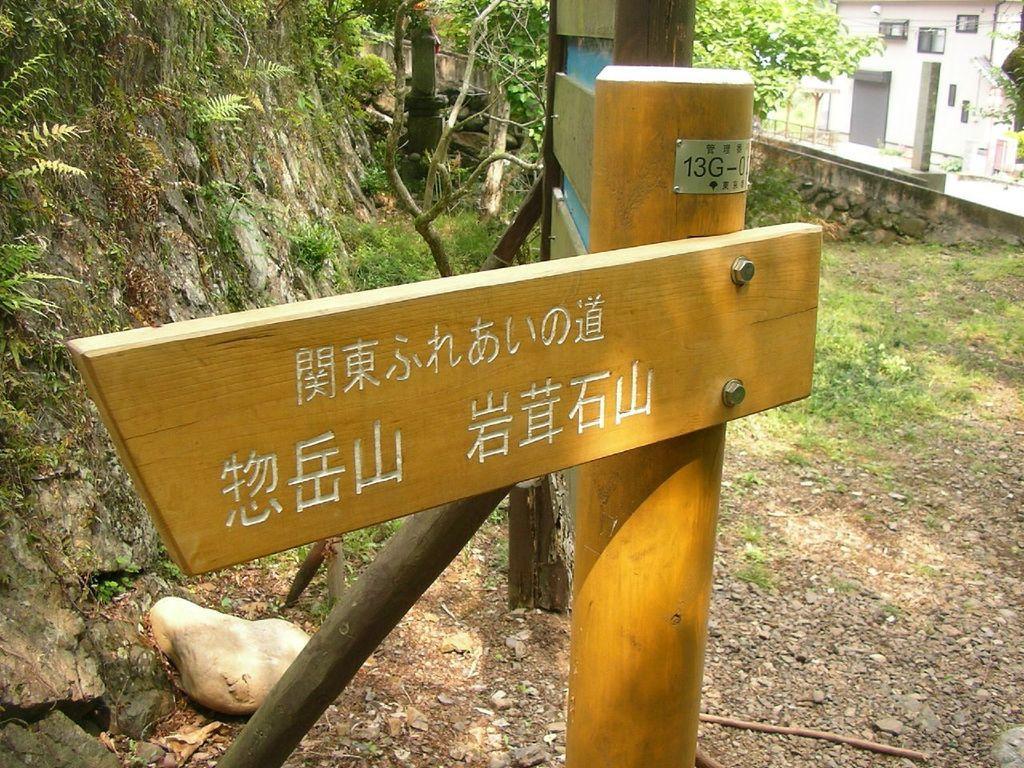Please provide a concise description of this image. In this image we can see wooden board on the pole, behind that there is a rock which is covered with plants, also we can see there are some buildings. 